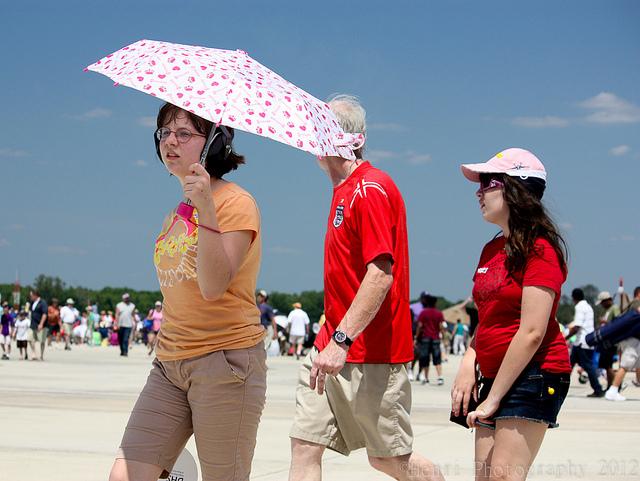Is it raining?
Give a very brief answer. No. What color shirt is the man wearing?
Quick response, please. Red. Is it a cold day?
Short answer required. No. What time of day is it?
Give a very brief answer. Afternoon. What is the woman in orange holding?
Keep it brief. Umbrella. 